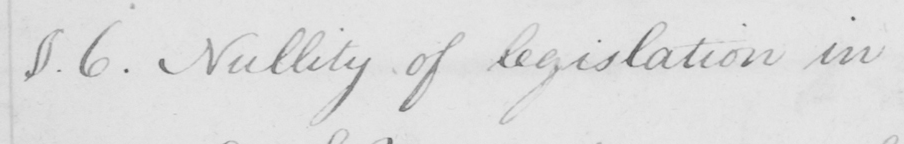Transcribe the text shown in this historical manuscript line. §.6 . Nullity of legislation in 